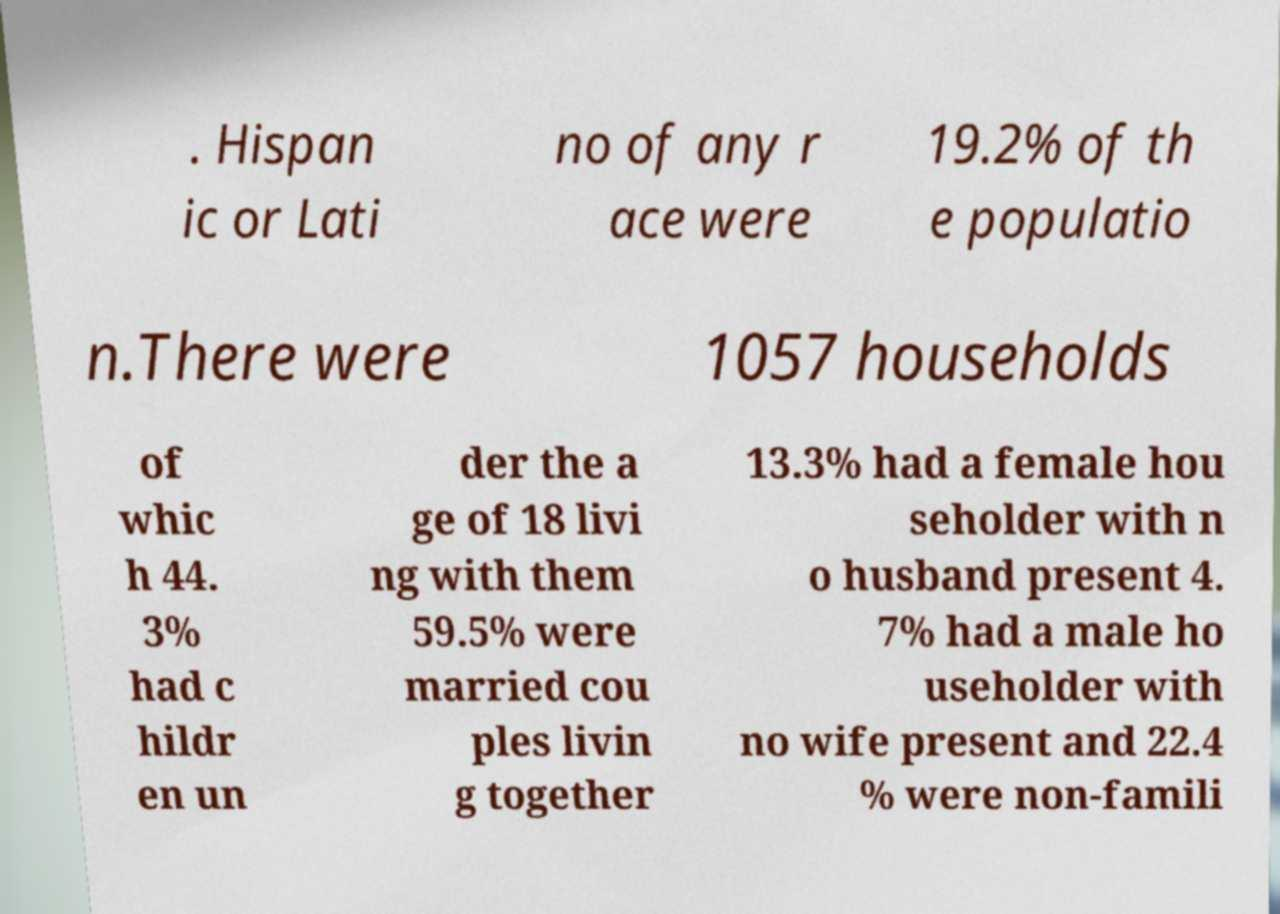Can you accurately transcribe the text from the provided image for me? . Hispan ic or Lati no of any r ace were 19.2% of th e populatio n.There were 1057 households of whic h 44. 3% had c hildr en un der the a ge of 18 livi ng with them 59.5% were married cou ples livin g together 13.3% had a female hou seholder with n o husband present 4. 7% had a male ho useholder with no wife present and 22.4 % were non-famili 